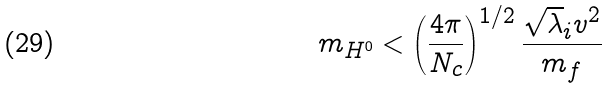<formula> <loc_0><loc_0><loc_500><loc_500>m _ { H ^ { 0 } } < \left ( \frac { 4 \pi } { N _ { c } } \right ) ^ { 1 / 2 } \frac { \sqrt { \lambda } _ { i } v ^ { 2 } } { m _ { f } }</formula> 